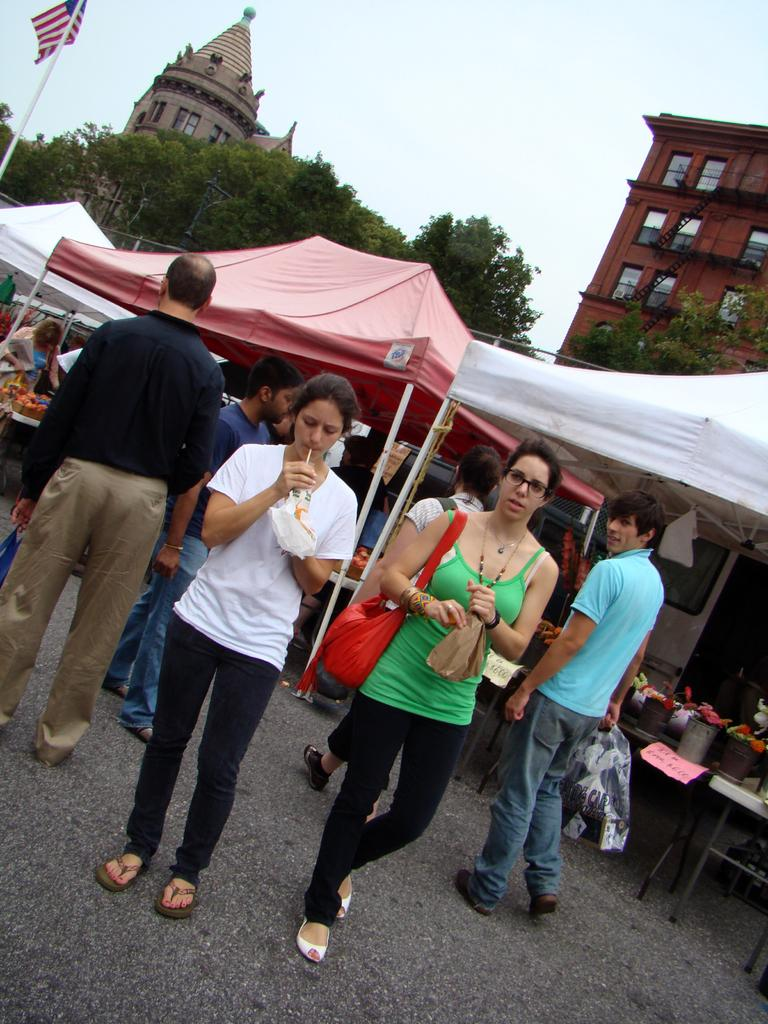What type of structures can be seen in the image? There are buildings in the image. What is the symbolic object located in the image? There is a flag in the image. What temporary shelters are present in the image? There are tents in the image. What vertical structure can be seen in the image? There is a pole in the image. What part of the natural environment is visible in the image? The sky and trees are visible in the image. Can you describe the people in the image? There are people in the image, and some of them are holding objects. What type of commercial establishments are present in the image? There are stalls in the image. What else can be seen in the image besides the mentioned elements? There are objects in the image. What type of pain is the porter experiencing in the image? There is no porter present in the image, and therefore no pain can be attributed to them. What is the source of shame in the image? There is no shame present in the image, as it features a scene with buildings, a flag, tents, a pole, the sky, trees, people, stalls, and objects. 